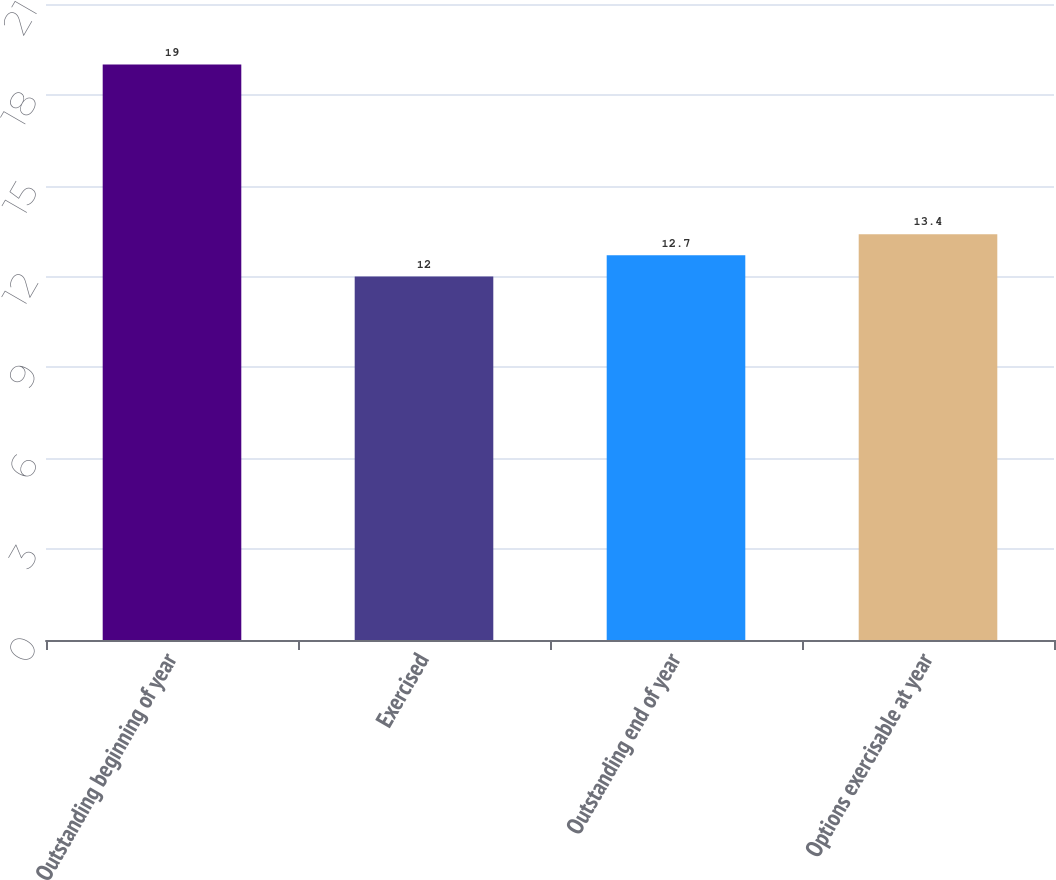Convert chart to OTSL. <chart><loc_0><loc_0><loc_500><loc_500><bar_chart><fcel>Outstanding beginning of year<fcel>Exercised<fcel>Outstanding end of year<fcel>Options exercisable at year<nl><fcel>19<fcel>12<fcel>12.7<fcel>13.4<nl></chart> 